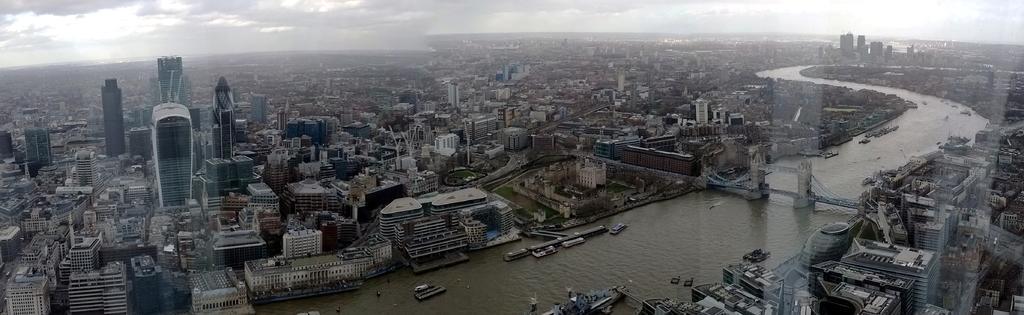In one or two sentences, can you explain what this image depicts? In this picture I can see number of buildings and in the middle of this image I see the water and I see the boats and on the right of this picture I see a bridge and in the background I see the sky which is cloudy. 